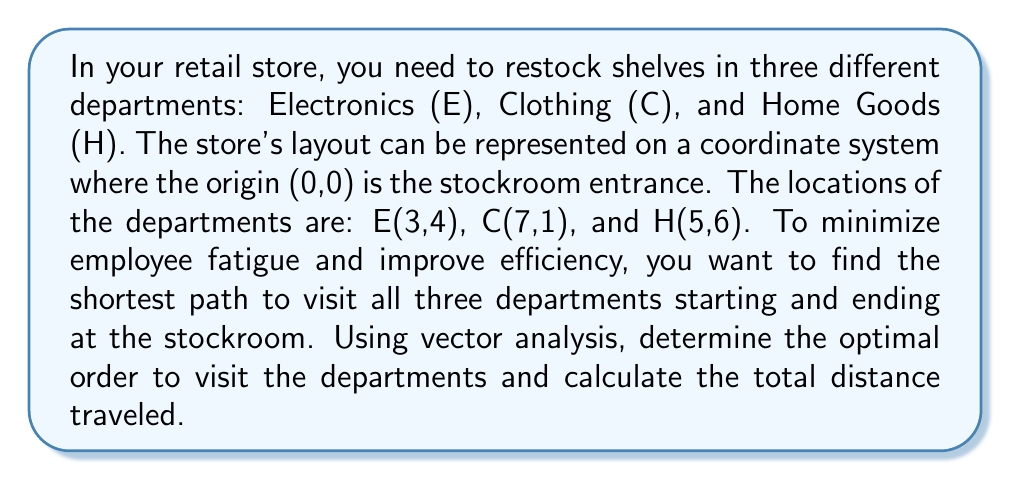Provide a solution to this math problem. To solve this problem, we'll use vector analysis and the concept of minimizing total distance traveled. Let's approach this step-by-step:

1) First, we need to calculate the distances between all points. We can do this using the distance formula derived from vector subtraction:

   Distance = $\sqrt{(x_2-x_1)^2 + (y_2-y_1)^2}$

2) Calculate distances:
   - Stockroom (S) to E: $\sqrt{(3-0)^2 + (4-0)^2} = 5$
   - S to C: $\sqrt{(7-0)^2 + (1-0)^2} = \sqrt{50} \approx 7.07$
   - S to H: $\sqrt{(5-0)^2 + (6-0)^2} = \sqrt{61} \approx 7.81$
   - E to C: $\sqrt{(7-3)^2 + (1-4)^2} = 5$
   - E to H: $\sqrt{(5-3)^2 + (6-4)^2} = 2\sqrt{5} \approx 4.47$
   - C to H: $\sqrt{(5-7)^2 + (6-1)^2} = \sqrt{41} \approx 6.40$

3) Now, we need to consider all possible paths:
   S-E-C-H-S, S-E-H-C-S, S-C-E-H-S, S-C-H-E-S, S-H-E-C-S, S-H-C-E-S

4) Calculate the total distance for each path:
   - S-E-C-H-S: $5 + 5 + 6.40 + 7.81 = 24.21$
   - S-E-H-C-S: $5 + 4.47 + 6.40 + 7.07 = 22.94$
   - S-C-E-H-S: $7.07 + 5 + 4.47 + 7.81 = 24.35$
   - S-C-H-E-S: $7.07 + 6.40 + 4.47 + 5 = 22.94$
   - S-H-E-C-S: $7.81 + 4.47 + 5 + 7.07 = 24.35$
   - S-H-C-E-S: $7.81 + 6.40 + 5 + 5 = 24.21$

5) The shortest paths are S-E-H-C-S and S-C-H-E-S, both with a total distance of 22.94 units.

6) We can represent these paths as vectors:
   S-E-H-C-S: $\vec{SE} + \vec{EH} + \vec{HC} + \vec{CS}$
   S-C-H-E-S: $\vec{SC} + \vec{CH} + \vec{HE} + \vec{ES}$

   Where each vector represents the displacement from one point to another.

Therefore, there are two optimal paths with the same minimum distance.
Answer: The optimal paths are Stockroom-Electronics-Home Goods-Clothing-Stockroom (S-E-H-C-S) or Stockroom-Clothing-Home Goods-Electronics-Stockroom (S-C-H-E-S), both with a total distance of approximately 22.94 units. 